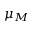Convert formula to latex. <formula><loc_0><loc_0><loc_500><loc_500>\mu _ { M }</formula> 